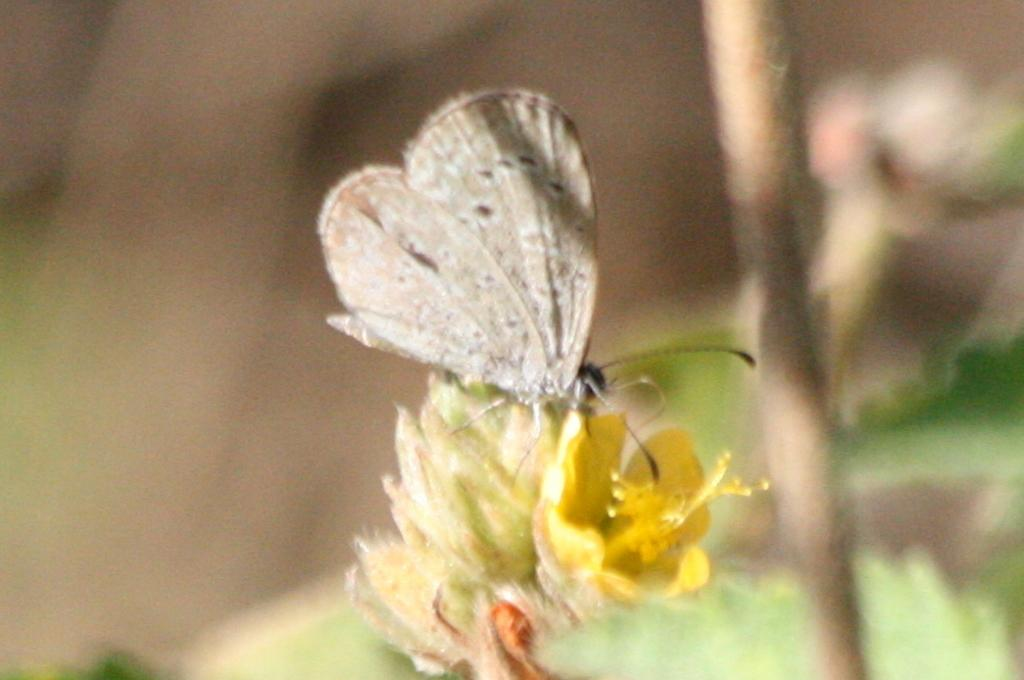What is the main subject of the image? There is a butterfly in the image. What is the butterfly doing in the image? The butterfly is on a yellow flower. What color is the butterfly? The butterfly is grey in color. How would you describe the background of the image? The background of the image is blurred. What is the name of the person holding the ring in the image? There is no person holding a ring in the image; it features a grey butterfly on a yellow flower with a blurred background. 